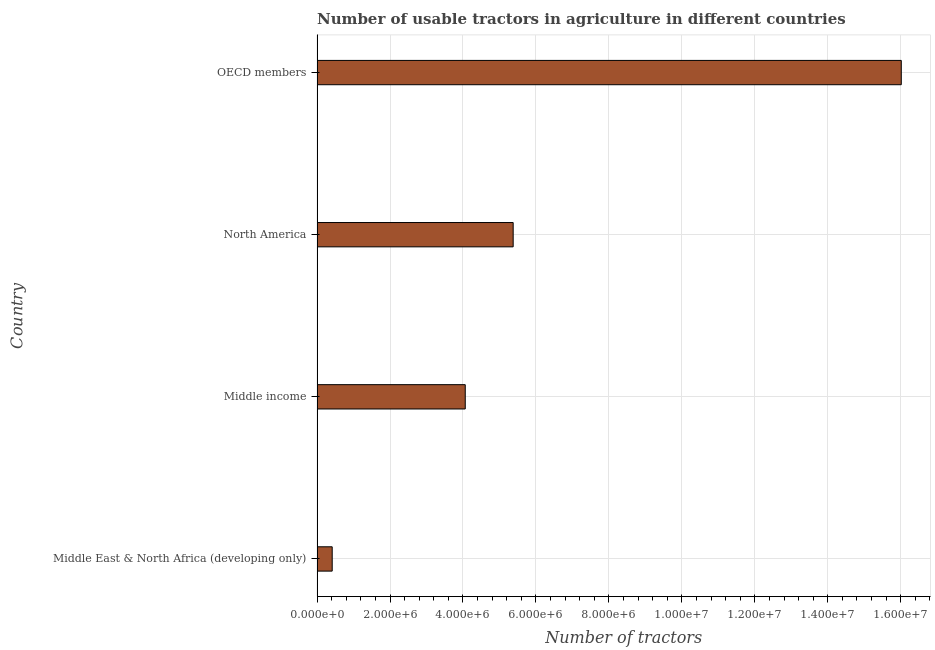Does the graph contain any zero values?
Ensure brevity in your answer.  No. Does the graph contain grids?
Your answer should be very brief. Yes. What is the title of the graph?
Keep it short and to the point. Number of usable tractors in agriculture in different countries. What is the label or title of the X-axis?
Provide a succinct answer. Number of tractors. What is the label or title of the Y-axis?
Your response must be concise. Country. What is the number of tractors in Middle income?
Make the answer very short. 4.06e+06. Across all countries, what is the maximum number of tractors?
Give a very brief answer. 1.60e+07. Across all countries, what is the minimum number of tractors?
Provide a short and direct response. 4.15e+05. In which country was the number of tractors maximum?
Provide a short and direct response. OECD members. In which country was the number of tractors minimum?
Ensure brevity in your answer.  Middle East & North Africa (developing only). What is the sum of the number of tractors?
Your answer should be very brief. 2.59e+07. What is the difference between the number of tractors in North America and OECD members?
Offer a terse response. -1.06e+07. What is the average number of tractors per country?
Your response must be concise. 6.47e+06. What is the median number of tractors?
Ensure brevity in your answer.  4.72e+06. What is the ratio of the number of tractors in Middle income to that in North America?
Make the answer very short. 0.76. Is the number of tractors in Middle East & North Africa (developing only) less than that in North America?
Offer a very short reply. Yes. Is the difference between the number of tractors in North America and OECD members greater than the difference between any two countries?
Make the answer very short. No. What is the difference between the highest and the second highest number of tractors?
Your answer should be very brief. 1.06e+07. Is the sum of the number of tractors in Middle East & North Africa (developing only) and Middle income greater than the maximum number of tractors across all countries?
Make the answer very short. No. What is the difference between the highest and the lowest number of tractors?
Provide a succinct answer. 1.56e+07. How many bars are there?
Ensure brevity in your answer.  4. How many countries are there in the graph?
Your answer should be compact. 4. Are the values on the major ticks of X-axis written in scientific E-notation?
Provide a succinct answer. Yes. What is the Number of tractors of Middle East & North Africa (developing only)?
Make the answer very short. 4.15e+05. What is the Number of tractors in Middle income?
Offer a terse response. 4.06e+06. What is the Number of tractors in North America?
Keep it short and to the point. 5.38e+06. What is the Number of tractors of OECD members?
Your answer should be compact. 1.60e+07. What is the difference between the Number of tractors in Middle East & North Africa (developing only) and Middle income?
Make the answer very short. -3.65e+06. What is the difference between the Number of tractors in Middle East & North Africa (developing only) and North America?
Provide a short and direct response. -4.96e+06. What is the difference between the Number of tractors in Middle East & North Africa (developing only) and OECD members?
Offer a terse response. -1.56e+07. What is the difference between the Number of tractors in Middle income and North America?
Your answer should be compact. -1.31e+06. What is the difference between the Number of tractors in Middle income and OECD members?
Give a very brief answer. -1.20e+07. What is the difference between the Number of tractors in North America and OECD members?
Ensure brevity in your answer.  -1.06e+07. What is the ratio of the Number of tractors in Middle East & North Africa (developing only) to that in Middle income?
Your answer should be very brief. 0.1. What is the ratio of the Number of tractors in Middle East & North Africa (developing only) to that in North America?
Offer a very short reply. 0.08. What is the ratio of the Number of tractors in Middle East & North Africa (developing only) to that in OECD members?
Offer a very short reply. 0.03. What is the ratio of the Number of tractors in Middle income to that in North America?
Make the answer very short. 0.76. What is the ratio of the Number of tractors in Middle income to that in OECD members?
Offer a very short reply. 0.25. What is the ratio of the Number of tractors in North America to that in OECD members?
Make the answer very short. 0.34. 